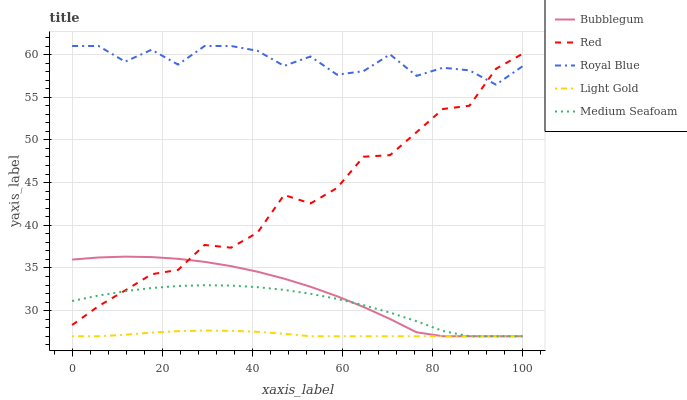Does Light Gold have the minimum area under the curve?
Answer yes or no. Yes. Does Royal Blue have the maximum area under the curve?
Answer yes or no. Yes. Does Red have the minimum area under the curve?
Answer yes or no. No. Does Red have the maximum area under the curve?
Answer yes or no. No. Is Light Gold the smoothest?
Answer yes or no. Yes. Is Royal Blue the roughest?
Answer yes or no. Yes. Is Red the smoothest?
Answer yes or no. No. Is Red the roughest?
Answer yes or no. No. Does Light Gold have the lowest value?
Answer yes or no. Yes. Does Red have the lowest value?
Answer yes or no. No. Does Royal Blue have the highest value?
Answer yes or no. Yes. Does Red have the highest value?
Answer yes or no. No. Is Medium Seafoam less than Royal Blue?
Answer yes or no. Yes. Is Royal Blue greater than Light Gold?
Answer yes or no. Yes. Does Medium Seafoam intersect Light Gold?
Answer yes or no. Yes. Is Medium Seafoam less than Light Gold?
Answer yes or no. No. Is Medium Seafoam greater than Light Gold?
Answer yes or no. No. Does Medium Seafoam intersect Royal Blue?
Answer yes or no. No. 